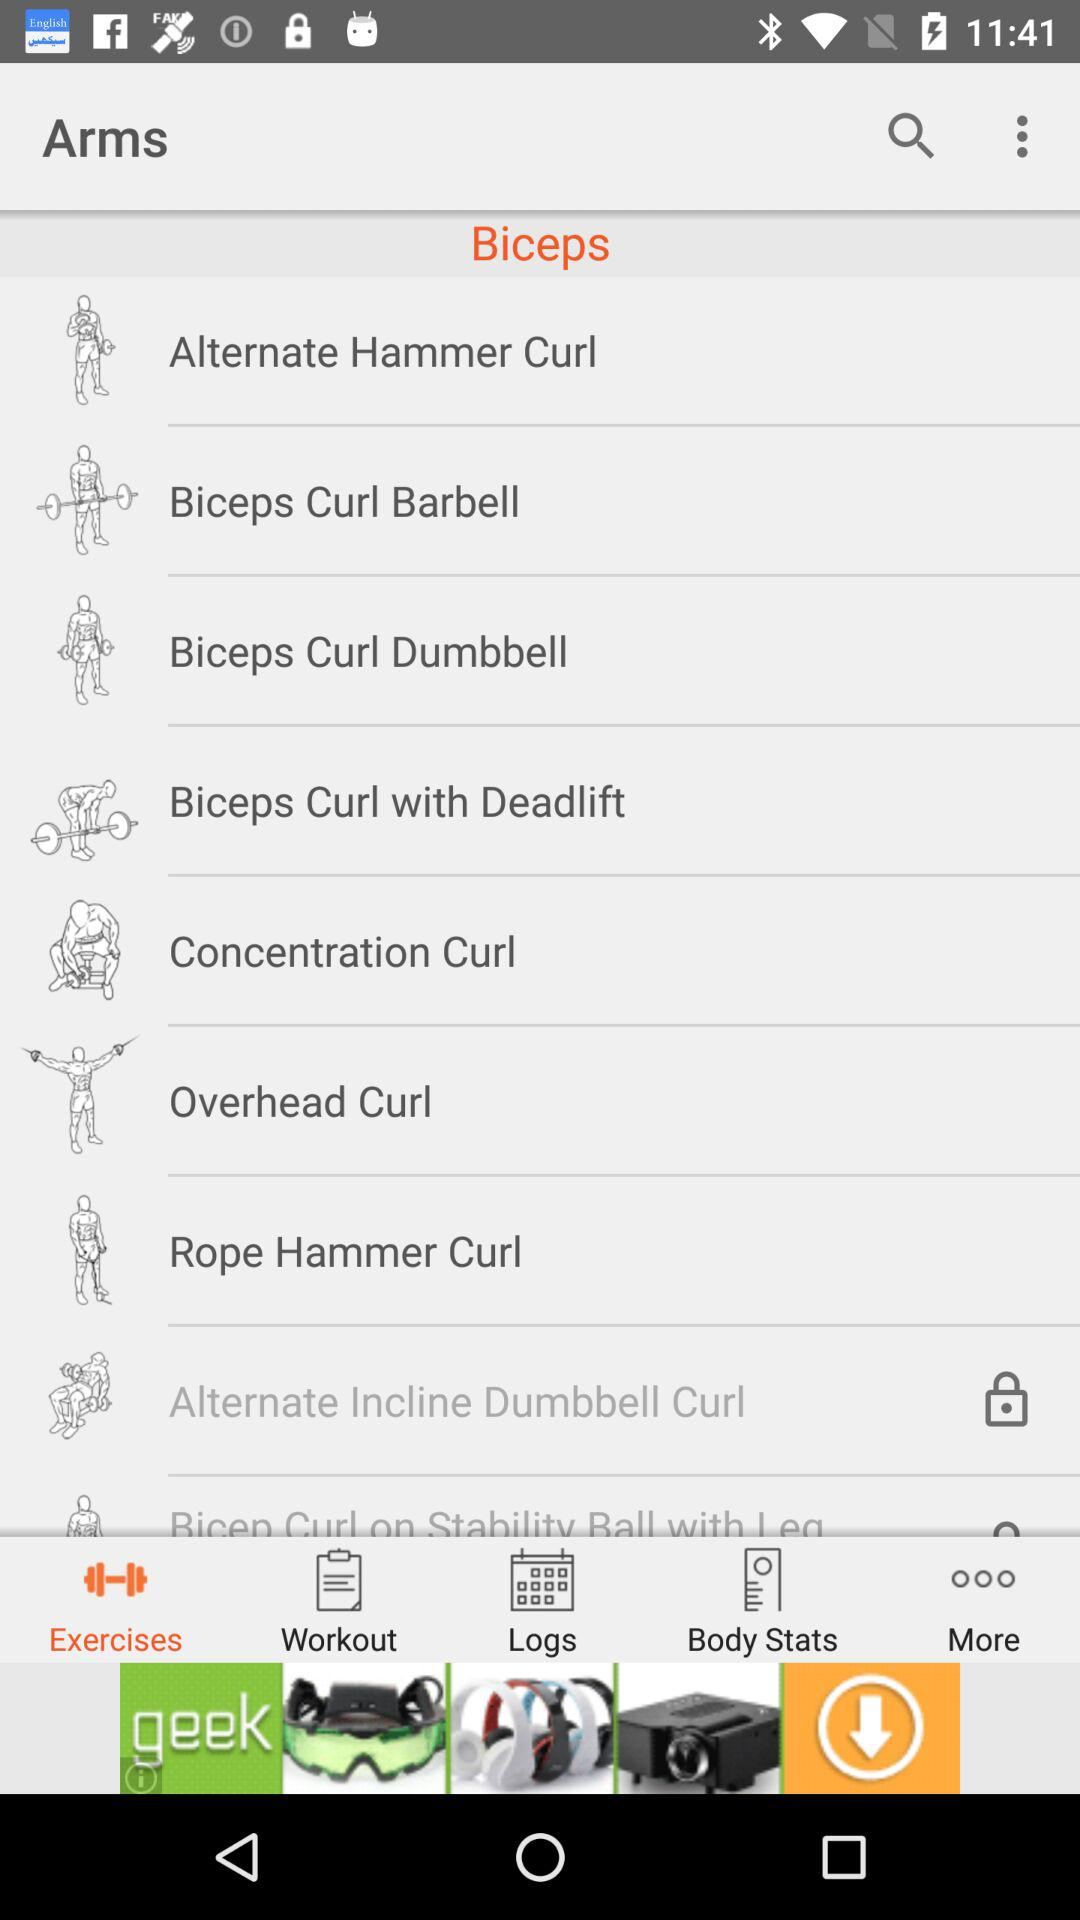What are the names of the biceps exercises? The biceps exercises are "Alternate Hammer Curl", "Biceps Curl Barbell", "Biceps Curl Dumbbell", "Biceps Curl with Deadlift", "Concentration Curl", "Overhead Curl", "Rope Hammer Curl" and "Alternate Incline Dumbell Curl". 